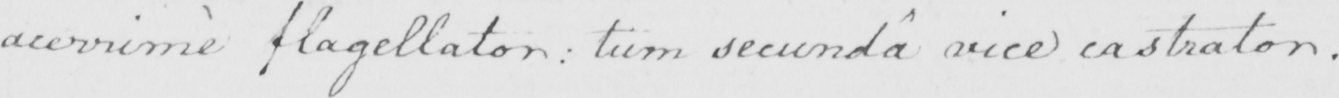Can you read and transcribe this handwriting? acerrime flagellator :  tum secunda vice castrator . 